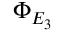<formula> <loc_0><loc_0><loc_500><loc_500>\Phi _ { E _ { 3 } }</formula> 